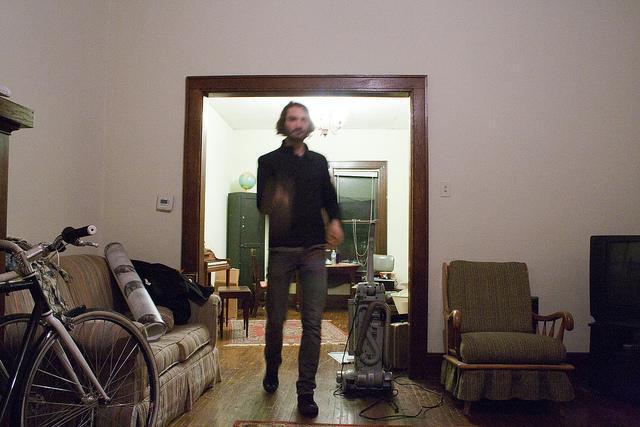How many cats are in this photo?
Give a very brief answer. 0. 